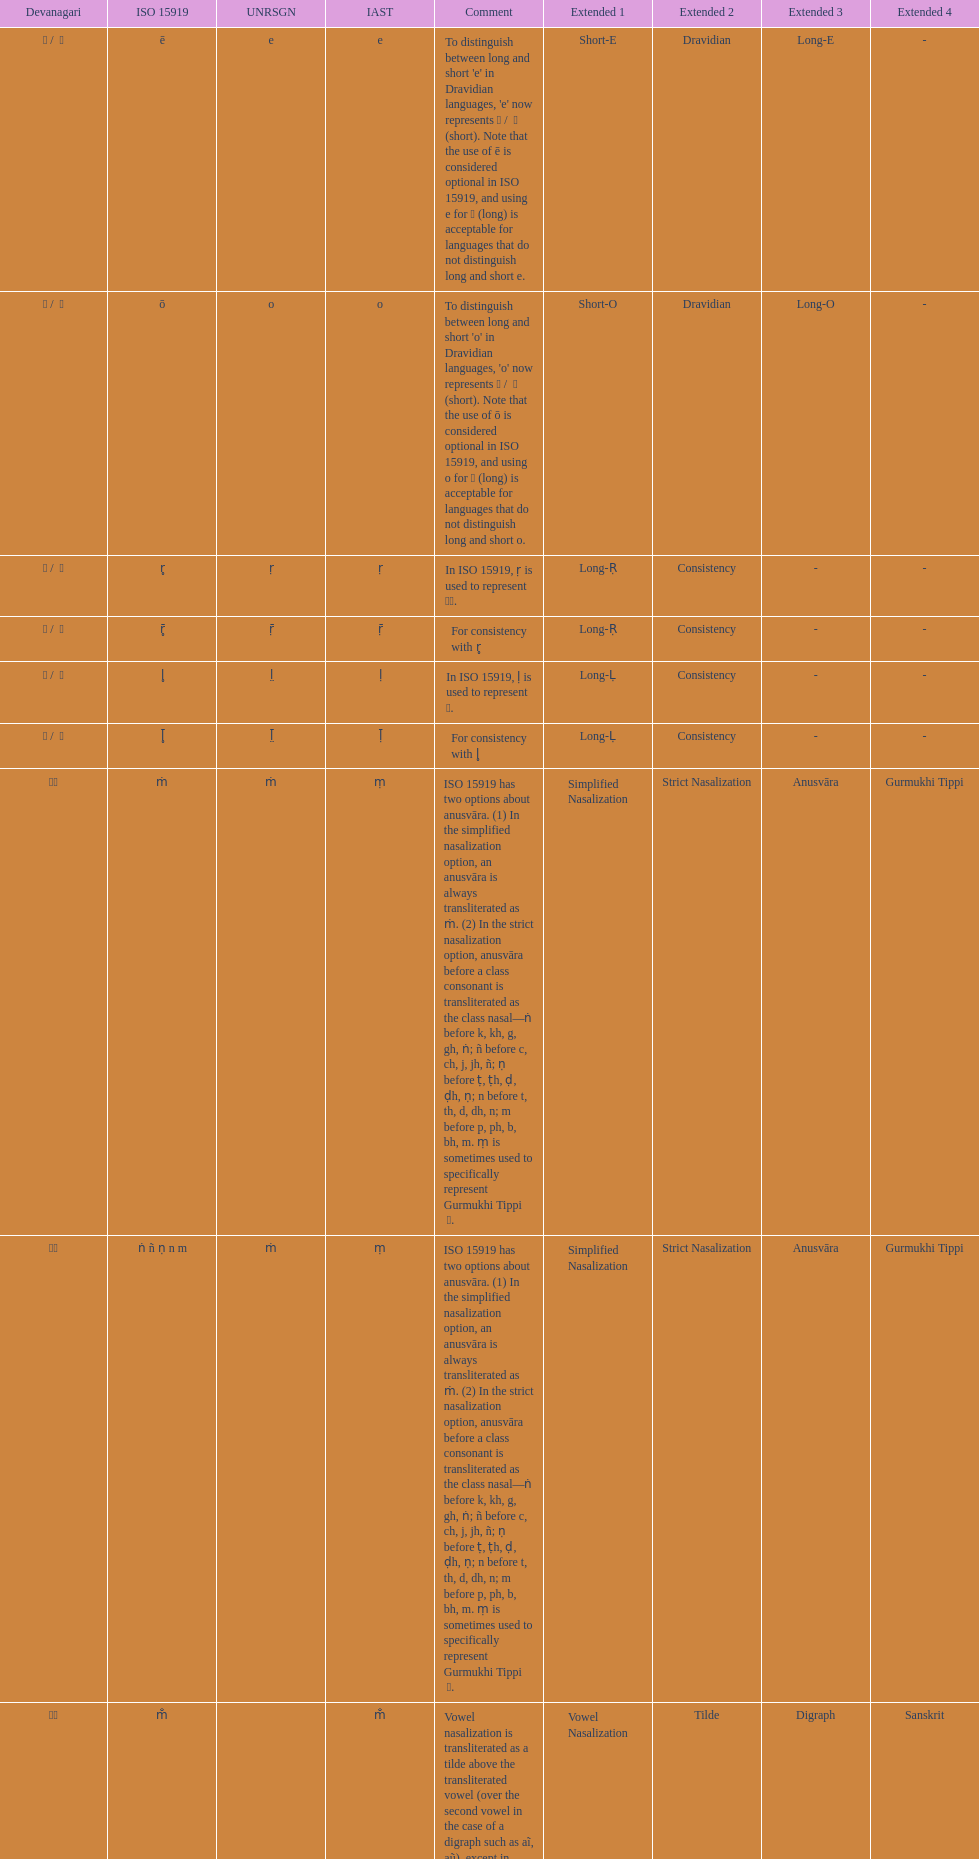What is the cumulative number of translations? 8. 